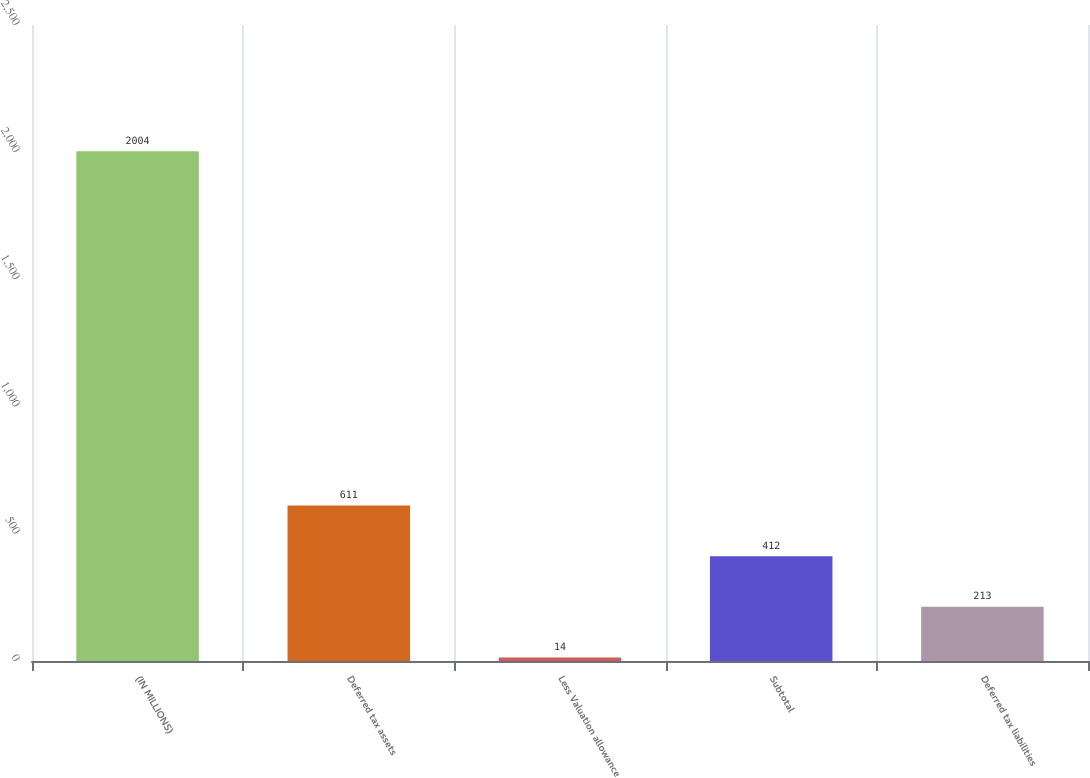Convert chart. <chart><loc_0><loc_0><loc_500><loc_500><bar_chart><fcel>(IN MILLIONS)<fcel>Deferred tax assets<fcel>Less Valuation allowance<fcel>Subtotal<fcel>Deferred tax liabilities<nl><fcel>2004<fcel>611<fcel>14<fcel>412<fcel>213<nl></chart> 